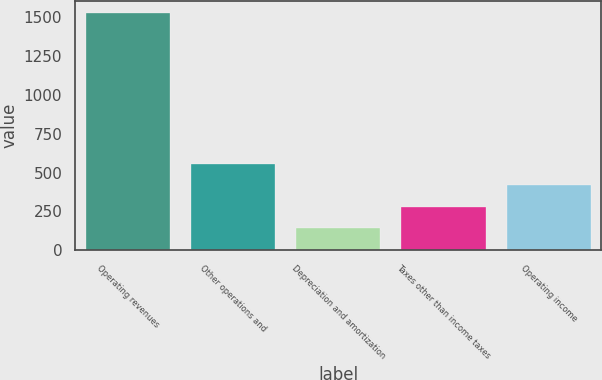Convert chart to OTSL. <chart><loc_0><loc_0><loc_500><loc_500><bar_chart><fcel>Operating revenues<fcel>Other operations and<fcel>Depreciation and amortization<fcel>Taxes other than income taxes<fcel>Operating income<nl><fcel>1527<fcel>557.5<fcel>142<fcel>280.5<fcel>419<nl></chart> 